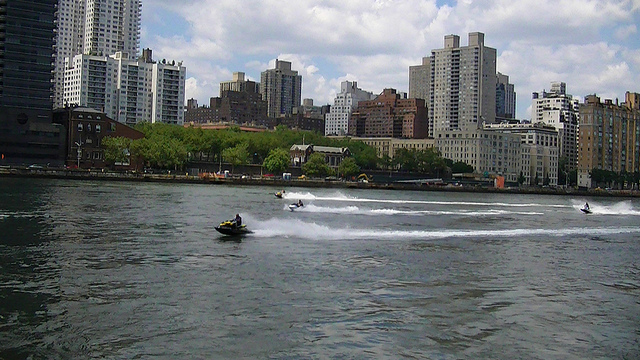<image>Where are they going? It is ambiguous where they are going. They could be going up river, down river, or just playing in the water. Where are they going? I don't know where they are going. They can be going up river, down river, or to the city. 